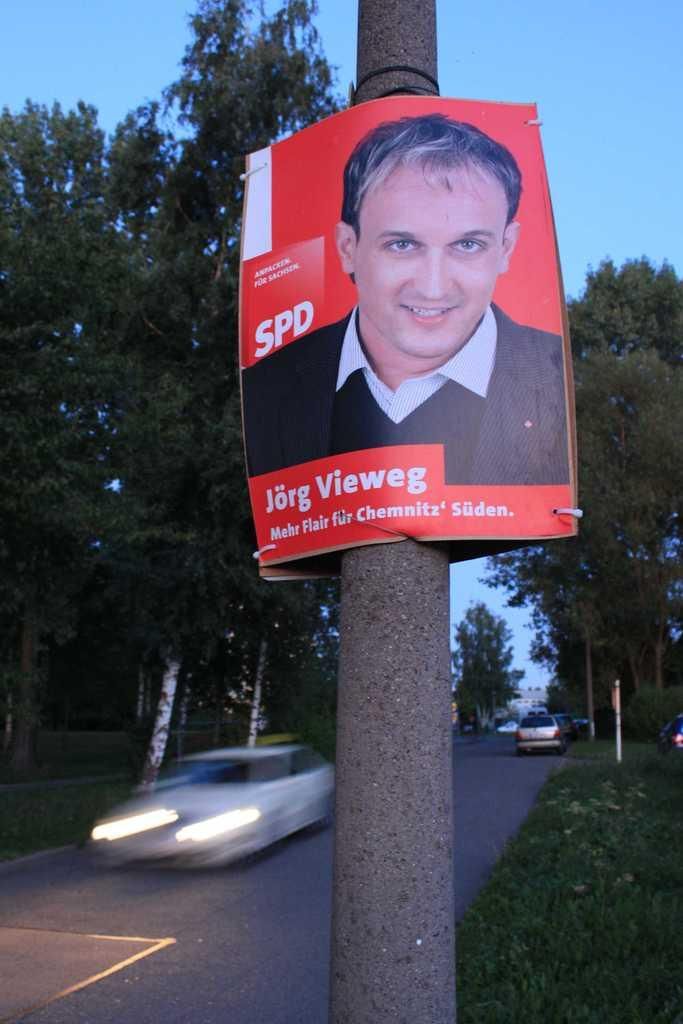What is located on the pole in the foreground of the image? There is a poster on a pole in the foreground of the image. What type of vegetation can be seen in the background of the image? There are trees and grass in the background of the image. What can be seen on the road in the background of the image? There are vehicles on the road in the background of the image. What is visible at the top of the image? The sky is visible at the top of the image. What type of curtain is hanging from the trees in the image? There are no curtains present in the image; it features a poster on a pole, trees, grass, vehicles, and the sky. 